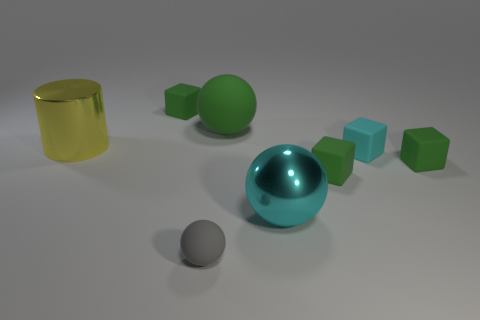Subtract all green blocks. How many were subtracted if there are1green blocks left? 2 Subtract all green spheres. How many spheres are left? 2 Subtract all gray spheres. How many green blocks are left? 3 Subtract all cyan blocks. How many blocks are left? 3 Add 1 big blue objects. How many objects exist? 9 Subtract all cylinders. How many objects are left? 7 Subtract all brown blocks. Subtract all green balls. How many blocks are left? 4 Add 6 green balls. How many green balls exist? 7 Subtract 0 purple cylinders. How many objects are left? 8 Subtract all big rubber objects. Subtract all small cyan things. How many objects are left? 6 